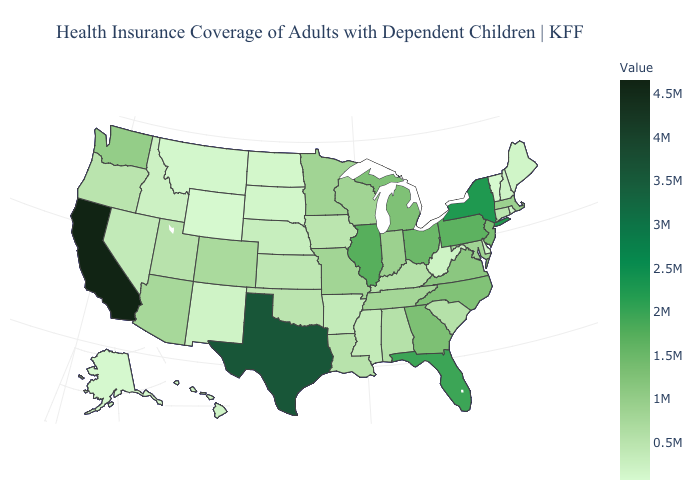Among the states that border Missouri , which have the lowest value?
Concise answer only. Nebraska. Among the states that border Iowa , does Minnesota have the lowest value?
Concise answer only. No. Among the states that border Washington , does Idaho have the highest value?
Be succinct. No. Which states have the highest value in the USA?
Keep it brief. California. Does the map have missing data?
Give a very brief answer. No. Among the states that border Indiana , does Michigan have the lowest value?
Keep it brief. No. Does Oregon have the highest value in the USA?
Be succinct. No. 